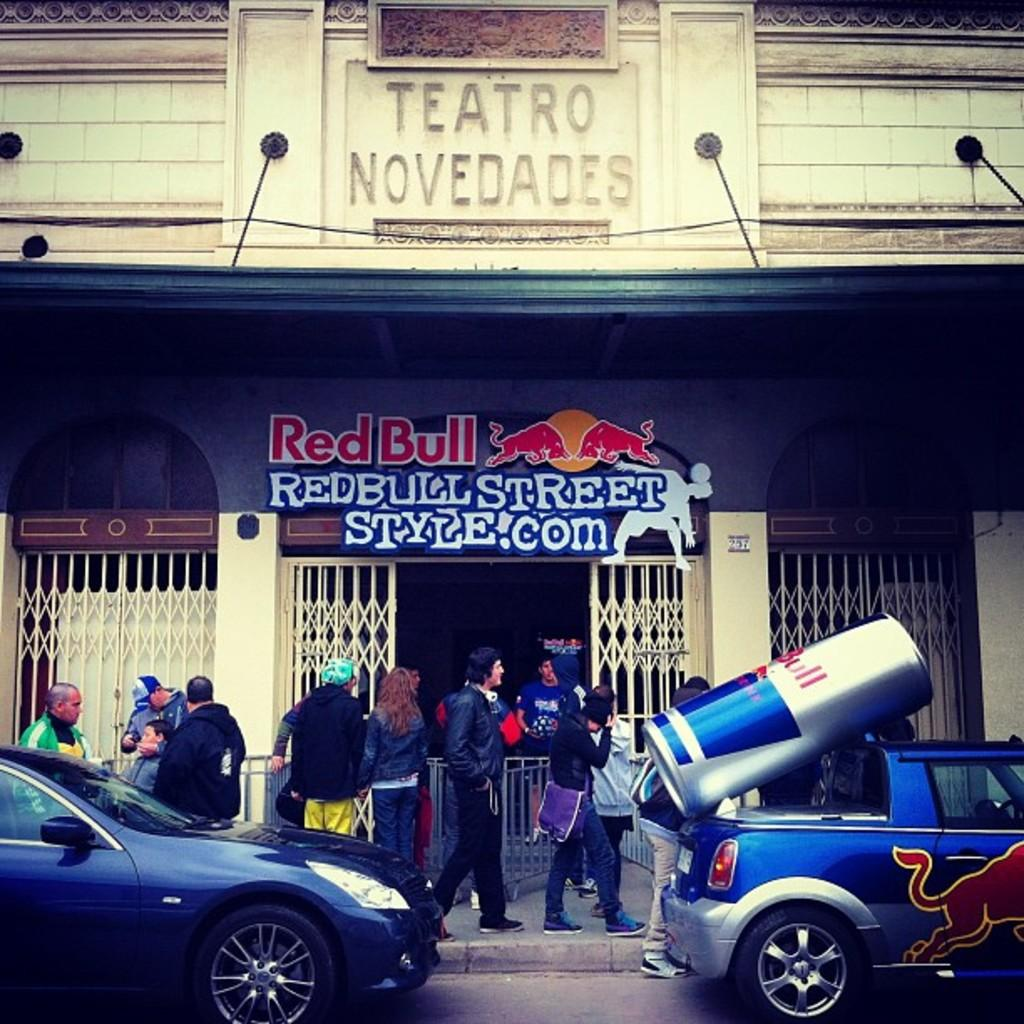What structure can be seen in the image? There is a building in the image. What is written on the board inside the building? There is text written on a board in the building. What are the people in the image doing? There are people walking in the image. What can be seen on the road at the bottom of the image? Vehicles are visible on the road at the bottom of the image. Where is the cobweb located in the image? There is no cobweb present in the image. What type of curve can be seen in the image? There is no curve present in the image. 